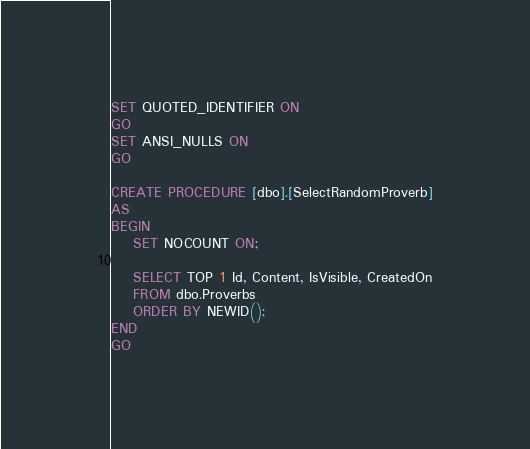<code> <loc_0><loc_0><loc_500><loc_500><_SQL_>
SET QUOTED_IDENTIFIER ON
GO
SET ANSI_NULLS ON
GO

CREATE PROCEDURE [dbo].[SelectRandomProverb]
AS
BEGIN
	SET NOCOUNT ON;

	SELECT TOP 1 Id, Content, IsVisible, CreatedOn
	FROM dbo.Proverbs 
	ORDER BY NEWID();
END
GO
</code> 